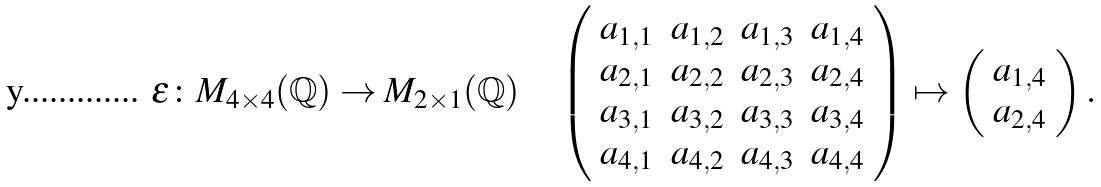Convert formula to latex. <formula><loc_0><loc_0><loc_500><loc_500>\epsilon \colon M _ { 4 \times 4 } ( \mathbb { Q } ) \rightarrow M _ { 2 \times 1 } ( \mathbb { Q } ) \quad \left ( \begin{array} { c c c c } a _ { 1 , 1 } & a _ { 1 , 2 } & a _ { 1 , 3 } & a _ { 1 , 4 } \\ a _ { 2 , 1 } & a _ { 2 , 2 } & a _ { 2 , 3 } & a _ { 2 , 4 } \\ a _ { 3 , 1 } & a _ { 3 , 2 } & a _ { 3 , 3 } & a _ { 3 , 4 } \\ a _ { 4 , 1 } & a _ { 4 , 2 } & a _ { 4 , 3 } & a _ { 4 , 4 } \end{array} \right ) \mapsto \left ( \begin{array} { c } a _ { 1 , 4 } \\ a _ { 2 , 4 } \end{array} \right ) .</formula> 